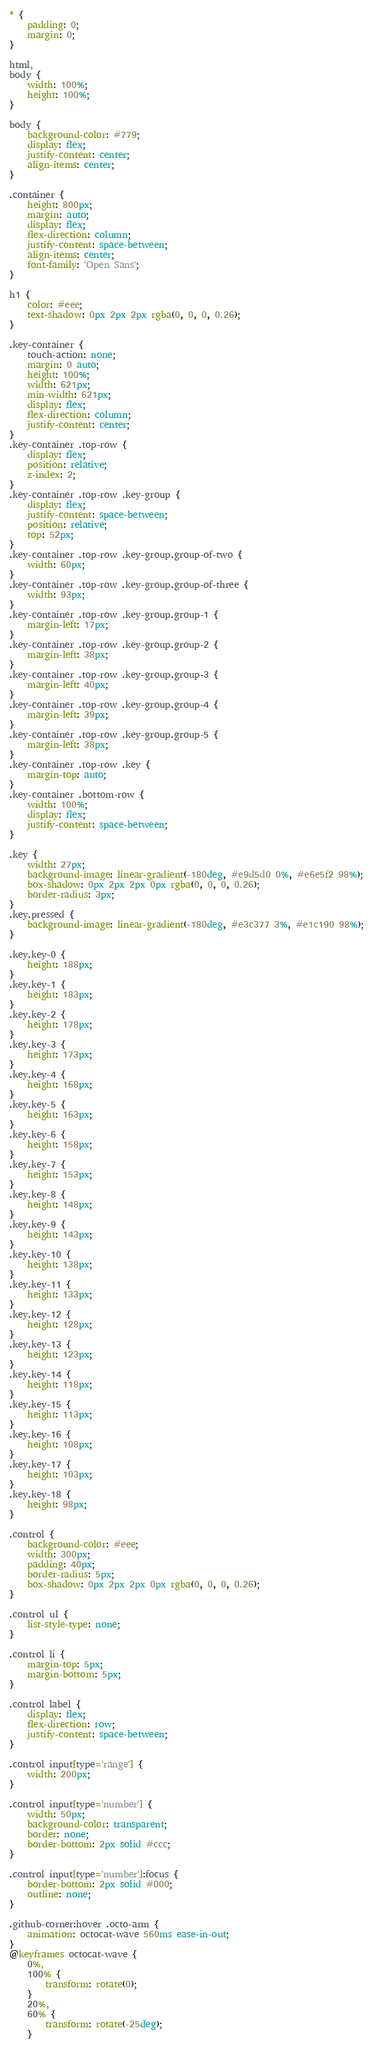<code> <loc_0><loc_0><loc_500><loc_500><_CSS_>* {
    padding: 0;
    margin: 0;
}

html,
body {
    width: 100%;
    height: 100%;
}

body {
    background-color: #779;
    display: flex;
    justify-content: center;
    align-items: center;
}

.container {
    height: 800px;
    margin: auto;
    display: flex;
    flex-direction: column;
    justify-content: space-between;
    align-items: center;
    font-family: 'Open Sans';
}

h1 {
    color: #eee;
    text-shadow: 0px 2px 2px rgba(0, 0, 0, 0.26);
}

.key-container {
    touch-action: none;
    margin: 0 auto;
    height: 100%;
    width: 621px;
    min-width: 621px;
    display: flex;
    flex-direction: column;
    justify-content: center;
}
.key-container .top-row {
    display: flex;
    position: relative;
    z-index: 2;
}
.key-container .top-row .key-group {
    display: flex;
    justify-content: space-between;
    position: relative;
    top: 52px;
}
.key-container .top-row .key-group.group-of-two {
    width: 60px;
}
.key-container .top-row .key-group.group-of-three {
    width: 93px;
}
.key-container .top-row .key-group.group-1 {
    margin-left: 17px;
}
.key-container .top-row .key-group.group-2 {
    margin-left: 38px;
}
.key-container .top-row .key-group.group-3 {
    margin-left: 40px;
}
.key-container .top-row .key-group.group-4 {
    margin-left: 39px;
}
.key-container .top-row .key-group.group-5 {
    margin-left: 38px;
}
.key-container .top-row .key {
    margin-top: auto;
}
.key-container .bottom-row {
    width: 100%;
    display: flex;
    justify-content: space-between;
}

.key {
    width: 27px;
    background-image: linear-gradient(-180deg, #e9d5d0 0%, #e6e5f2 98%);
    box-shadow: 0px 2px 2px 0px rgba(0, 0, 0, 0.26);
    border-radius: 3px;
}
.key.pressed {
    background-image: linear-gradient(-180deg, #e3c377 3%, #e1c190 98%);
}

.key.key-0 {
    height: 188px;
}
.key.key-1 {
    height: 183px;
}
.key.key-2 {
    height: 178px;
}
.key.key-3 {
    height: 173px;
}
.key.key-4 {
    height: 168px;
}
.key.key-5 {
    height: 163px;
}
.key.key-6 {
    height: 158px;
}
.key.key-7 {
    height: 153px;
}
.key.key-8 {
    height: 148px;
}
.key.key-9 {
    height: 143px;
}
.key.key-10 {
    height: 138px;
}
.key.key-11 {
    height: 133px;
}
.key.key-12 {
    height: 128px;
}
.key.key-13 {
    height: 123px;
}
.key.key-14 {
    height: 118px;
}
.key.key-15 {
    height: 113px;
}
.key.key-16 {
    height: 108px;
}
.key.key-17 {
    height: 103px;
}
.key.key-18 {
    height: 98px;
}

.control {
    background-color: #eee;
    width: 300px;
    padding: 40px;
    border-radius: 5px;
    box-shadow: 0px 2px 2px 0px rgba(0, 0, 0, 0.26);
}

.control ul {
    list-style-type: none;
}

.control li {
    margin-top: 5px;
    margin-bottom: 5px;
}

.control label {
    display: flex;
    flex-direction: row;
    justify-content: space-between;
}

.control input[type='range'] {
    width: 200px;
}

.control input[type='number'] {
    width: 50px;
    background-color: transparent;
    border: none;
    border-bottom: 2px solid #ccc;
}

.control input[type='number']:focus {
    border-bottom: 2px solid #000;
    outline: none;
}

.github-corner:hover .octo-arm {
    animation: octocat-wave 560ms ease-in-out;
}
@keyframes octocat-wave {
    0%,
    100% {
        transform: rotate(0);
    }
    20%,
    60% {
        transform: rotate(-25deg);
    }</code> 